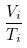<formula> <loc_0><loc_0><loc_500><loc_500>\frac { V _ { i } } { T _ { i } }</formula> 